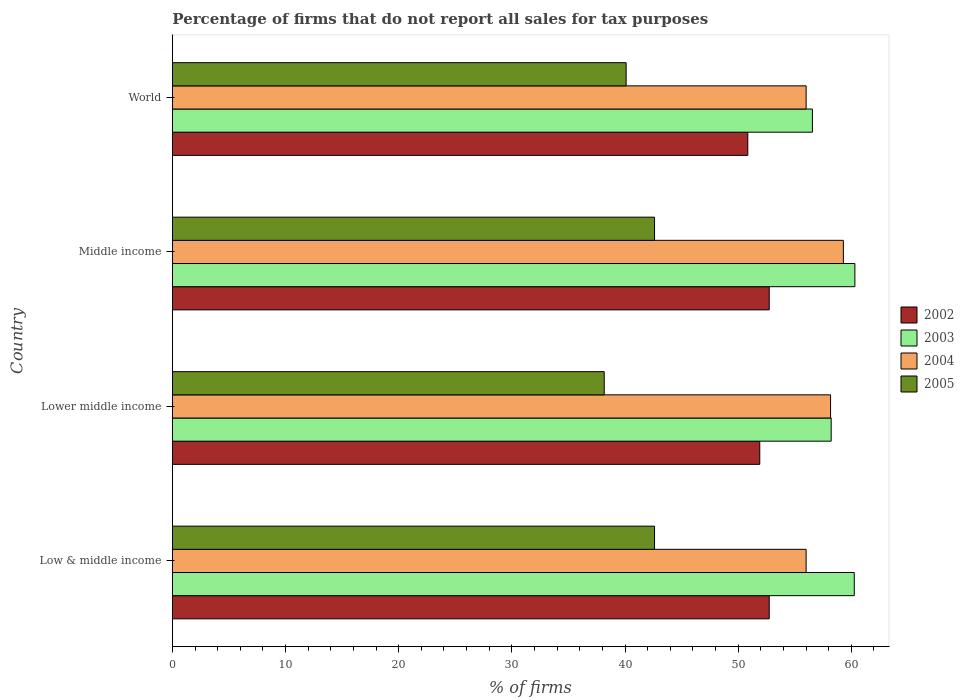How many bars are there on the 4th tick from the bottom?
Your answer should be compact. 4. In how many cases, is the number of bars for a given country not equal to the number of legend labels?
Provide a succinct answer. 0. What is the percentage of firms that do not report all sales for tax purposes in 2005 in Middle income?
Offer a terse response. 42.61. Across all countries, what is the maximum percentage of firms that do not report all sales for tax purposes in 2005?
Your response must be concise. 42.61. Across all countries, what is the minimum percentage of firms that do not report all sales for tax purposes in 2005?
Provide a short and direct response. 38.16. In which country was the percentage of firms that do not report all sales for tax purposes in 2005 minimum?
Offer a very short reply. Lower middle income. What is the total percentage of firms that do not report all sales for tax purposes in 2004 in the graph?
Provide a succinct answer. 229.47. What is the difference between the percentage of firms that do not report all sales for tax purposes in 2003 in Middle income and that in World?
Offer a terse response. 3.75. What is the difference between the percentage of firms that do not report all sales for tax purposes in 2004 in Lower middle income and the percentage of firms that do not report all sales for tax purposes in 2003 in World?
Give a very brief answer. 1.6. What is the average percentage of firms that do not report all sales for tax purposes in 2004 per country?
Provide a succinct answer. 57.37. What is the difference between the percentage of firms that do not report all sales for tax purposes in 2005 and percentage of firms that do not report all sales for tax purposes in 2002 in Middle income?
Your answer should be compact. -10.13. What is the ratio of the percentage of firms that do not report all sales for tax purposes in 2004 in Lower middle income to that in Middle income?
Make the answer very short. 0.98. Is the percentage of firms that do not report all sales for tax purposes in 2005 in Middle income less than that in World?
Provide a short and direct response. No. Is the difference between the percentage of firms that do not report all sales for tax purposes in 2005 in Low & middle income and Middle income greater than the difference between the percentage of firms that do not report all sales for tax purposes in 2002 in Low & middle income and Middle income?
Make the answer very short. No. What is the difference between the highest and the second highest percentage of firms that do not report all sales for tax purposes in 2003?
Your answer should be very brief. 0.05. What is the difference between the highest and the lowest percentage of firms that do not report all sales for tax purposes in 2004?
Keep it short and to the point. 3.29. In how many countries, is the percentage of firms that do not report all sales for tax purposes in 2005 greater than the average percentage of firms that do not report all sales for tax purposes in 2005 taken over all countries?
Provide a succinct answer. 2. Is it the case that in every country, the sum of the percentage of firms that do not report all sales for tax purposes in 2003 and percentage of firms that do not report all sales for tax purposes in 2005 is greater than the sum of percentage of firms that do not report all sales for tax purposes in 2002 and percentage of firms that do not report all sales for tax purposes in 2004?
Make the answer very short. No. Are all the bars in the graph horizontal?
Provide a short and direct response. Yes. What is the difference between two consecutive major ticks on the X-axis?
Your answer should be very brief. 10. Does the graph contain grids?
Keep it short and to the point. No. How are the legend labels stacked?
Your response must be concise. Vertical. What is the title of the graph?
Keep it short and to the point. Percentage of firms that do not report all sales for tax purposes. What is the label or title of the X-axis?
Provide a succinct answer. % of firms. What is the % of firms of 2002 in Low & middle income?
Ensure brevity in your answer.  52.75. What is the % of firms of 2003 in Low & middle income?
Your response must be concise. 60.26. What is the % of firms in 2004 in Low & middle income?
Your answer should be very brief. 56.01. What is the % of firms of 2005 in Low & middle income?
Your response must be concise. 42.61. What is the % of firms of 2002 in Lower middle income?
Ensure brevity in your answer.  51.91. What is the % of firms in 2003 in Lower middle income?
Provide a succinct answer. 58.22. What is the % of firms of 2004 in Lower middle income?
Offer a very short reply. 58.16. What is the % of firms of 2005 in Lower middle income?
Offer a very short reply. 38.16. What is the % of firms in 2002 in Middle income?
Offer a terse response. 52.75. What is the % of firms in 2003 in Middle income?
Your response must be concise. 60.31. What is the % of firms in 2004 in Middle income?
Your answer should be compact. 59.3. What is the % of firms of 2005 in Middle income?
Give a very brief answer. 42.61. What is the % of firms of 2002 in World?
Make the answer very short. 50.85. What is the % of firms in 2003 in World?
Offer a very short reply. 56.56. What is the % of firms of 2004 in World?
Your answer should be compact. 56.01. What is the % of firms of 2005 in World?
Provide a succinct answer. 40.1. Across all countries, what is the maximum % of firms in 2002?
Offer a terse response. 52.75. Across all countries, what is the maximum % of firms of 2003?
Give a very brief answer. 60.31. Across all countries, what is the maximum % of firms of 2004?
Make the answer very short. 59.3. Across all countries, what is the maximum % of firms of 2005?
Your answer should be very brief. 42.61. Across all countries, what is the minimum % of firms of 2002?
Offer a terse response. 50.85. Across all countries, what is the minimum % of firms in 2003?
Keep it short and to the point. 56.56. Across all countries, what is the minimum % of firms of 2004?
Offer a very short reply. 56.01. Across all countries, what is the minimum % of firms of 2005?
Give a very brief answer. 38.16. What is the total % of firms of 2002 in the graph?
Your answer should be compact. 208.25. What is the total % of firms of 2003 in the graph?
Keep it short and to the point. 235.35. What is the total % of firms in 2004 in the graph?
Offer a terse response. 229.47. What is the total % of firms in 2005 in the graph?
Offer a very short reply. 163.48. What is the difference between the % of firms of 2002 in Low & middle income and that in Lower middle income?
Your answer should be compact. 0.84. What is the difference between the % of firms in 2003 in Low & middle income and that in Lower middle income?
Your response must be concise. 2.04. What is the difference between the % of firms in 2004 in Low & middle income and that in Lower middle income?
Offer a very short reply. -2.16. What is the difference between the % of firms of 2005 in Low & middle income and that in Lower middle income?
Give a very brief answer. 4.45. What is the difference between the % of firms of 2002 in Low & middle income and that in Middle income?
Provide a short and direct response. 0. What is the difference between the % of firms in 2003 in Low & middle income and that in Middle income?
Provide a short and direct response. -0.05. What is the difference between the % of firms of 2004 in Low & middle income and that in Middle income?
Provide a succinct answer. -3.29. What is the difference between the % of firms in 2002 in Low & middle income and that in World?
Keep it short and to the point. 1.89. What is the difference between the % of firms in 2005 in Low & middle income and that in World?
Offer a terse response. 2.51. What is the difference between the % of firms in 2002 in Lower middle income and that in Middle income?
Make the answer very short. -0.84. What is the difference between the % of firms in 2003 in Lower middle income and that in Middle income?
Provide a succinct answer. -2.09. What is the difference between the % of firms in 2004 in Lower middle income and that in Middle income?
Provide a short and direct response. -1.13. What is the difference between the % of firms in 2005 in Lower middle income and that in Middle income?
Make the answer very short. -4.45. What is the difference between the % of firms in 2002 in Lower middle income and that in World?
Give a very brief answer. 1.06. What is the difference between the % of firms of 2003 in Lower middle income and that in World?
Your answer should be compact. 1.66. What is the difference between the % of firms of 2004 in Lower middle income and that in World?
Your answer should be compact. 2.16. What is the difference between the % of firms in 2005 in Lower middle income and that in World?
Ensure brevity in your answer.  -1.94. What is the difference between the % of firms of 2002 in Middle income and that in World?
Provide a short and direct response. 1.89. What is the difference between the % of firms in 2003 in Middle income and that in World?
Your answer should be compact. 3.75. What is the difference between the % of firms in 2004 in Middle income and that in World?
Your answer should be compact. 3.29. What is the difference between the % of firms of 2005 in Middle income and that in World?
Offer a very short reply. 2.51. What is the difference between the % of firms in 2002 in Low & middle income and the % of firms in 2003 in Lower middle income?
Your answer should be compact. -5.47. What is the difference between the % of firms of 2002 in Low & middle income and the % of firms of 2004 in Lower middle income?
Keep it short and to the point. -5.42. What is the difference between the % of firms of 2002 in Low & middle income and the % of firms of 2005 in Lower middle income?
Your answer should be very brief. 14.58. What is the difference between the % of firms in 2003 in Low & middle income and the % of firms in 2004 in Lower middle income?
Ensure brevity in your answer.  2.1. What is the difference between the % of firms in 2003 in Low & middle income and the % of firms in 2005 in Lower middle income?
Your answer should be very brief. 22.1. What is the difference between the % of firms of 2004 in Low & middle income and the % of firms of 2005 in Lower middle income?
Give a very brief answer. 17.84. What is the difference between the % of firms in 2002 in Low & middle income and the % of firms in 2003 in Middle income?
Your response must be concise. -7.57. What is the difference between the % of firms in 2002 in Low & middle income and the % of firms in 2004 in Middle income?
Your answer should be compact. -6.55. What is the difference between the % of firms of 2002 in Low & middle income and the % of firms of 2005 in Middle income?
Your answer should be very brief. 10.13. What is the difference between the % of firms in 2003 in Low & middle income and the % of firms in 2004 in Middle income?
Your answer should be very brief. 0.96. What is the difference between the % of firms of 2003 in Low & middle income and the % of firms of 2005 in Middle income?
Your response must be concise. 17.65. What is the difference between the % of firms of 2004 in Low & middle income and the % of firms of 2005 in Middle income?
Your answer should be very brief. 13.39. What is the difference between the % of firms of 2002 in Low & middle income and the % of firms of 2003 in World?
Offer a terse response. -3.81. What is the difference between the % of firms of 2002 in Low & middle income and the % of firms of 2004 in World?
Offer a terse response. -3.26. What is the difference between the % of firms of 2002 in Low & middle income and the % of firms of 2005 in World?
Offer a terse response. 12.65. What is the difference between the % of firms of 2003 in Low & middle income and the % of firms of 2004 in World?
Make the answer very short. 4.25. What is the difference between the % of firms of 2003 in Low & middle income and the % of firms of 2005 in World?
Your response must be concise. 20.16. What is the difference between the % of firms in 2004 in Low & middle income and the % of firms in 2005 in World?
Make the answer very short. 15.91. What is the difference between the % of firms in 2002 in Lower middle income and the % of firms in 2003 in Middle income?
Give a very brief answer. -8.4. What is the difference between the % of firms in 2002 in Lower middle income and the % of firms in 2004 in Middle income?
Ensure brevity in your answer.  -7.39. What is the difference between the % of firms in 2002 in Lower middle income and the % of firms in 2005 in Middle income?
Your answer should be very brief. 9.3. What is the difference between the % of firms in 2003 in Lower middle income and the % of firms in 2004 in Middle income?
Your response must be concise. -1.08. What is the difference between the % of firms in 2003 in Lower middle income and the % of firms in 2005 in Middle income?
Offer a very short reply. 15.61. What is the difference between the % of firms of 2004 in Lower middle income and the % of firms of 2005 in Middle income?
Make the answer very short. 15.55. What is the difference between the % of firms in 2002 in Lower middle income and the % of firms in 2003 in World?
Ensure brevity in your answer.  -4.65. What is the difference between the % of firms in 2002 in Lower middle income and the % of firms in 2004 in World?
Provide a succinct answer. -4.1. What is the difference between the % of firms in 2002 in Lower middle income and the % of firms in 2005 in World?
Provide a succinct answer. 11.81. What is the difference between the % of firms of 2003 in Lower middle income and the % of firms of 2004 in World?
Provide a short and direct response. 2.21. What is the difference between the % of firms in 2003 in Lower middle income and the % of firms in 2005 in World?
Offer a very short reply. 18.12. What is the difference between the % of firms in 2004 in Lower middle income and the % of firms in 2005 in World?
Give a very brief answer. 18.07. What is the difference between the % of firms in 2002 in Middle income and the % of firms in 2003 in World?
Ensure brevity in your answer.  -3.81. What is the difference between the % of firms of 2002 in Middle income and the % of firms of 2004 in World?
Make the answer very short. -3.26. What is the difference between the % of firms of 2002 in Middle income and the % of firms of 2005 in World?
Offer a very short reply. 12.65. What is the difference between the % of firms of 2003 in Middle income and the % of firms of 2004 in World?
Your answer should be very brief. 4.31. What is the difference between the % of firms in 2003 in Middle income and the % of firms in 2005 in World?
Keep it short and to the point. 20.21. What is the difference between the % of firms of 2004 in Middle income and the % of firms of 2005 in World?
Make the answer very short. 19.2. What is the average % of firms of 2002 per country?
Provide a succinct answer. 52.06. What is the average % of firms in 2003 per country?
Your answer should be compact. 58.84. What is the average % of firms of 2004 per country?
Keep it short and to the point. 57.37. What is the average % of firms in 2005 per country?
Your answer should be compact. 40.87. What is the difference between the % of firms of 2002 and % of firms of 2003 in Low & middle income?
Make the answer very short. -7.51. What is the difference between the % of firms of 2002 and % of firms of 2004 in Low & middle income?
Offer a very short reply. -3.26. What is the difference between the % of firms in 2002 and % of firms in 2005 in Low & middle income?
Make the answer very short. 10.13. What is the difference between the % of firms of 2003 and % of firms of 2004 in Low & middle income?
Provide a succinct answer. 4.25. What is the difference between the % of firms in 2003 and % of firms in 2005 in Low & middle income?
Give a very brief answer. 17.65. What is the difference between the % of firms of 2004 and % of firms of 2005 in Low & middle income?
Offer a very short reply. 13.39. What is the difference between the % of firms of 2002 and % of firms of 2003 in Lower middle income?
Ensure brevity in your answer.  -6.31. What is the difference between the % of firms of 2002 and % of firms of 2004 in Lower middle income?
Your response must be concise. -6.26. What is the difference between the % of firms of 2002 and % of firms of 2005 in Lower middle income?
Offer a terse response. 13.75. What is the difference between the % of firms in 2003 and % of firms in 2004 in Lower middle income?
Your answer should be compact. 0.05. What is the difference between the % of firms in 2003 and % of firms in 2005 in Lower middle income?
Provide a succinct answer. 20.06. What is the difference between the % of firms of 2004 and % of firms of 2005 in Lower middle income?
Offer a very short reply. 20. What is the difference between the % of firms of 2002 and % of firms of 2003 in Middle income?
Provide a succinct answer. -7.57. What is the difference between the % of firms of 2002 and % of firms of 2004 in Middle income?
Offer a terse response. -6.55. What is the difference between the % of firms in 2002 and % of firms in 2005 in Middle income?
Keep it short and to the point. 10.13. What is the difference between the % of firms of 2003 and % of firms of 2004 in Middle income?
Provide a short and direct response. 1.02. What is the difference between the % of firms in 2003 and % of firms in 2005 in Middle income?
Your answer should be compact. 17.7. What is the difference between the % of firms in 2004 and % of firms in 2005 in Middle income?
Provide a short and direct response. 16.69. What is the difference between the % of firms of 2002 and % of firms of 2003 in World?
Give a very brief answer. -5.71. What is the difference between the % of firms in 2002 and % of firms in 2004 in World?
Provide a short and direct response. -5.15. What is the difference between the % of firms in 2002 and % of firms in 2005 in World?
Offer a very short reply. 10.75. What is the difference between the % of firms of 2003 and % of firms of 2004 in World?
Keep it short and to the point. 0.56. What is the difference between the % of firms in 2003 and % of firms in 2005 in World?
Ensure brevity in your answer.  16.46. What is the difference between the % of firms of 2004 and % of firms of 2005 in World?
Offer a terse response. 15.91. What is the ratio of the % of firms of 2002 in Low & middle income to that in Lower middle income?
Make the answer very short. 1.02. What is the ratio of the % of firms of 2003 in Low & middle income to that in Lower middle income?
Offer a terse response. 1.04. What is the ratio of the % of firms in 2004 in Low & middle income to that in Lower middle income?
Offer a very short reply. 0.96. What is the ratio of the % of firms in 2005 in Low & middle income to that in Lower middle income?
Your response must be concise. 1.12. What is the ratio of the % of firms of 2003 in Low & middle income to that in Middle income?
Your answer should be compact. 1. What is the ratio of the % of firms in 2004 in Low & middle income to that in Middle income?
Provide a short and direct response. 0.94. What is the ratio of the % of firms of 2002 in Low & middle income to that in World?
Your response must be concise. 1.04. What is the ratio of the % of firms of 2003 in Low & middle income to that in World?
Keep it short and to the point. 1.07. What is the ratio of the % of firms in 2005 in Low & middle income to that in World?
Give a very brief answer. 1.06. What is the ratio of the % of firms in 2002 in Lower middle income to that in Middle income?
Offer a very short reply. 0.98. What is the ratio of the % of firms of 2003 in Lower middle income to that in Middle income?
Offer a very short reply. 0.97. What is the ratio of the % of firms of 2004 in Lower middle income to that in Middle income?
Make the answer very short. 0.98. What is the ratio of the % of firms in 2005 in Lower middle income to that in Middle income?
Provide a succinct answer. 0.9. What is the ratio of the % of firms of 2002 in Lower middle income to that in World?
Offer a terse response. 1.02. What is the ratio of the % of firms in 2003 in Lower middle income to that in World?
Make the answer very short. 1.03. What is the ratio of the % of firms in 2004 in Lower middle income to that in World?
Offer a very short reply. 1.04. What is the ratio of the % of firms of 2005 in Lower middle income to that in World?
Make the answer very short. 0.95. What is the ratio of the % of firms in 2002 in Middle income to that in World?
Provide a succinct answer. 1.04. What is the ratio of the % of firms in 2003 in Middle income to that in World?
Give a very brief answer. 1.07. What is the ratio of the % of firms of 2004 in Middle income to that in World?
Make the answer very short. 1.06. What is the ratio of the % of firms in 2005 in Middle income to that in World?
Give a very brief answer. 1.06. What is the difference between the highest and the second highest % of firms in 2003?
Your response must be concise. 0.05. What is the difference between the highest and the second highest % of firms in 2004?
Offer a very short reply. 1.13. What is the difference between the highest and the second highest % of firms in 2005?
Give a very brief answer. 0. What is the difference between the highest and the lowest % of firms of 2002?
Ensure brevity in your answer.  1.89. What is the difference between the highest and the lowest % of firms in 2003?
Provide a succinct answer. 3.75. What is the difference between the highest and the lowest % of firms of 2004?
Ensure brevity in your answer.  3.29. What is the difference between the highest and the lowest % of firms of 2005?
Your answer should be compact. 4.45. 